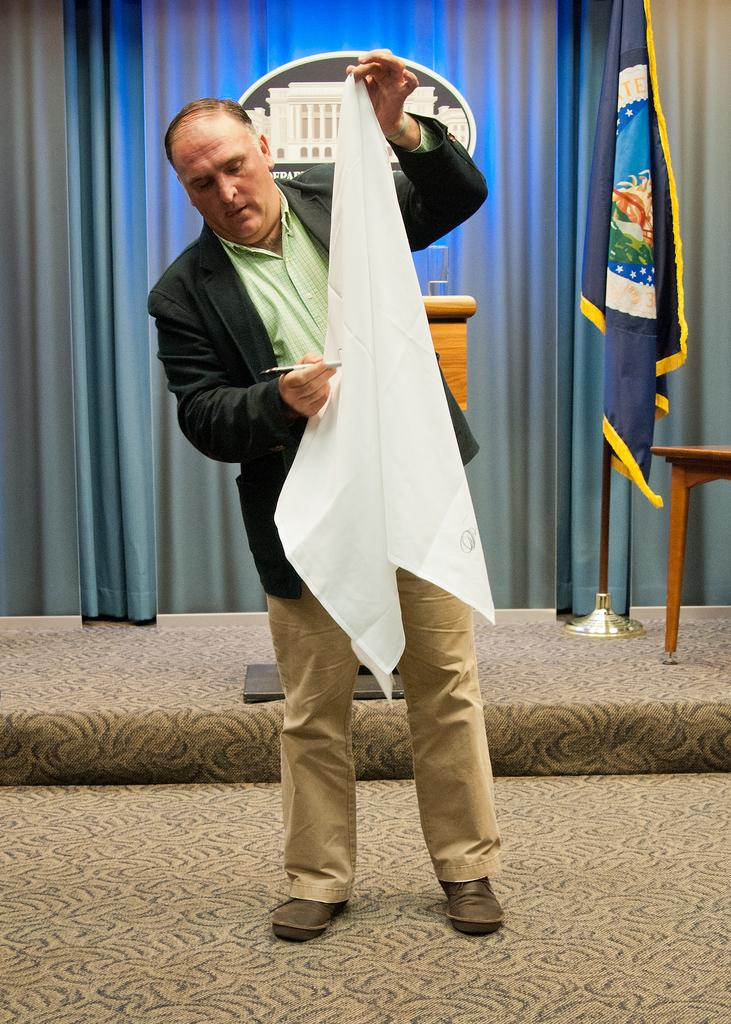Who is the main subject in the picture? There is an old man in the picture. What is the old man doing in the picture? The old man is standing. What objects is the old man holding in the picture? The old man is holding a white cloth in one hand and a pen in the other hand. What type of lumber is the old man using to write with in the image? There is no lumber present in the image, and the old man is using a pen to write. Can you see a card being held by the old man in the image? There is no card visible in the image; the old man is holding a white cloth and a pen. 